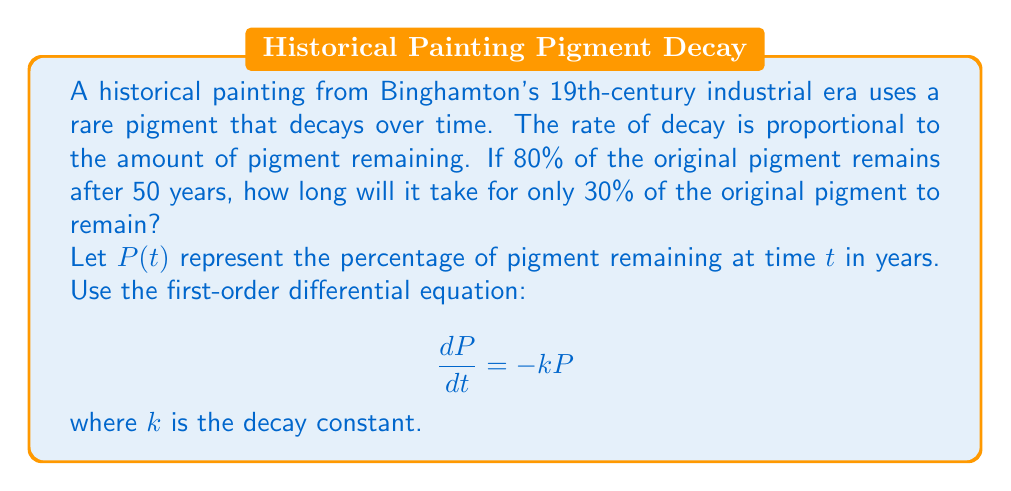Teach me how to tackle this problem. To solve this problem, we'll follow these steps:

1) First, we need to find the decay constant $k$ using the given information that 80% of the pigment remains after 50 years.

2) The solution to the differential equation $\frac{dP}{dt} = -kP$ is:

   $$P(t) = P_0e^{-kt}$$

   where $P_0$ is the initial amount of pigment (100%).

3) Substituting the known values:

   $$80 = 100e^{-50k}$$

4) Solving for $k$:

   $$0.8 = e^{-50k}$$
   $$\ln(0.8) = -50k$$
   $$k = -\frac{\ln(0.8)}{50} \approx 0.00446$$

5) Now that we have $k$, we can find the time $t$ when 30% of the pigment remains:

   $$30 = 100e^{-0.00446t}$$

6) Solving for $t$:

   $$0.3 = e^{-0.00446t}$$
   $$\ln(0.3) = -0.00446t$$
   $$t = -\frac{\ln(0.3)}{0.00446} \approx 268.2$$

Therefore, it will take approximately 268.2 years for only 30% of the original pigment to remain.
Answer: Approximately 268.2 years 